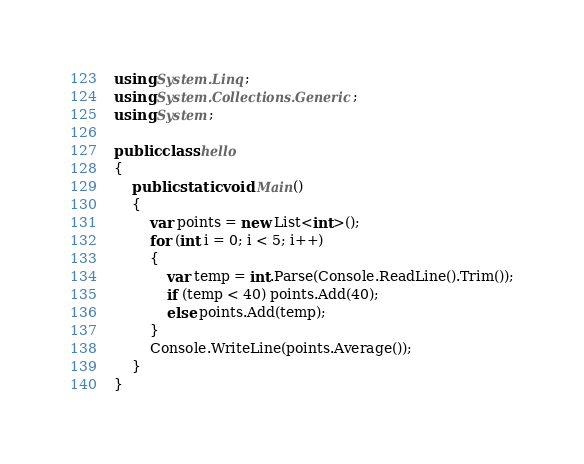Convert code to text. <code><loc_0><loc_0><loc_500><loc_500><_C#_>using System.Linq;
using System.Collections.Generic;
using System;

public class hello
{
    public static void Main()
    {
        var points = new List<int>();
        for (int i = 0; i < 5; i++)
        {
            var temp = int.Parse(Console.ReadLine().Trim());
            if (temp < 40) points.Add(40);
            else points.Add(temp);
        }
        Console.WriteLine(points.Average());
    }
}</code> 